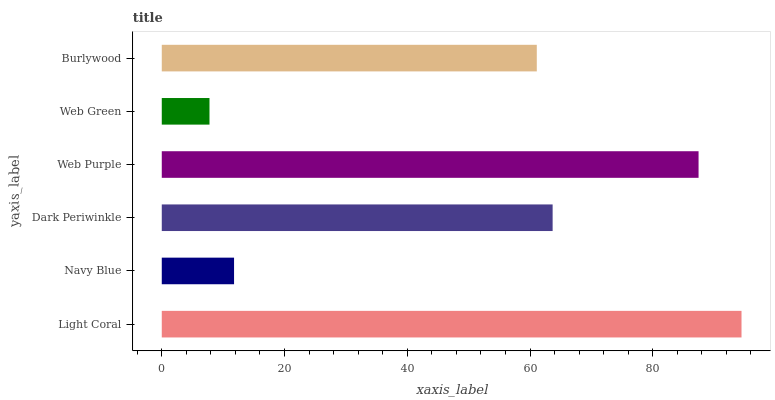Is Web Green the minimum?
Answer yes or no. Yes. Is Light Coral the maximum?
Answer yes or no. Yes. Is Navy Blue the minimum?
Answer yes or no. No. Is Navy Blue the maximum?
Answer yes or no. No. Is Light Coral greater than Navy Blue?
Answer yes or no. Yes. Is Navy Blue less than Light Coral?
Answer yes or no. Yes. Is Navy Blue greater than Light Coral?
Answer yes or no. No. Is Light Coral less than Navy Blue?
Answer yes or no. No. Is Dark Periwinkle the high median?
Answer yes or no. Yes. Is Burlywood the low median?
Answer yes or no. Yes. Is Light Coral the high median?
Answer yes or no. No. Is Web Purple the low median?
Answer yes or no. No. 